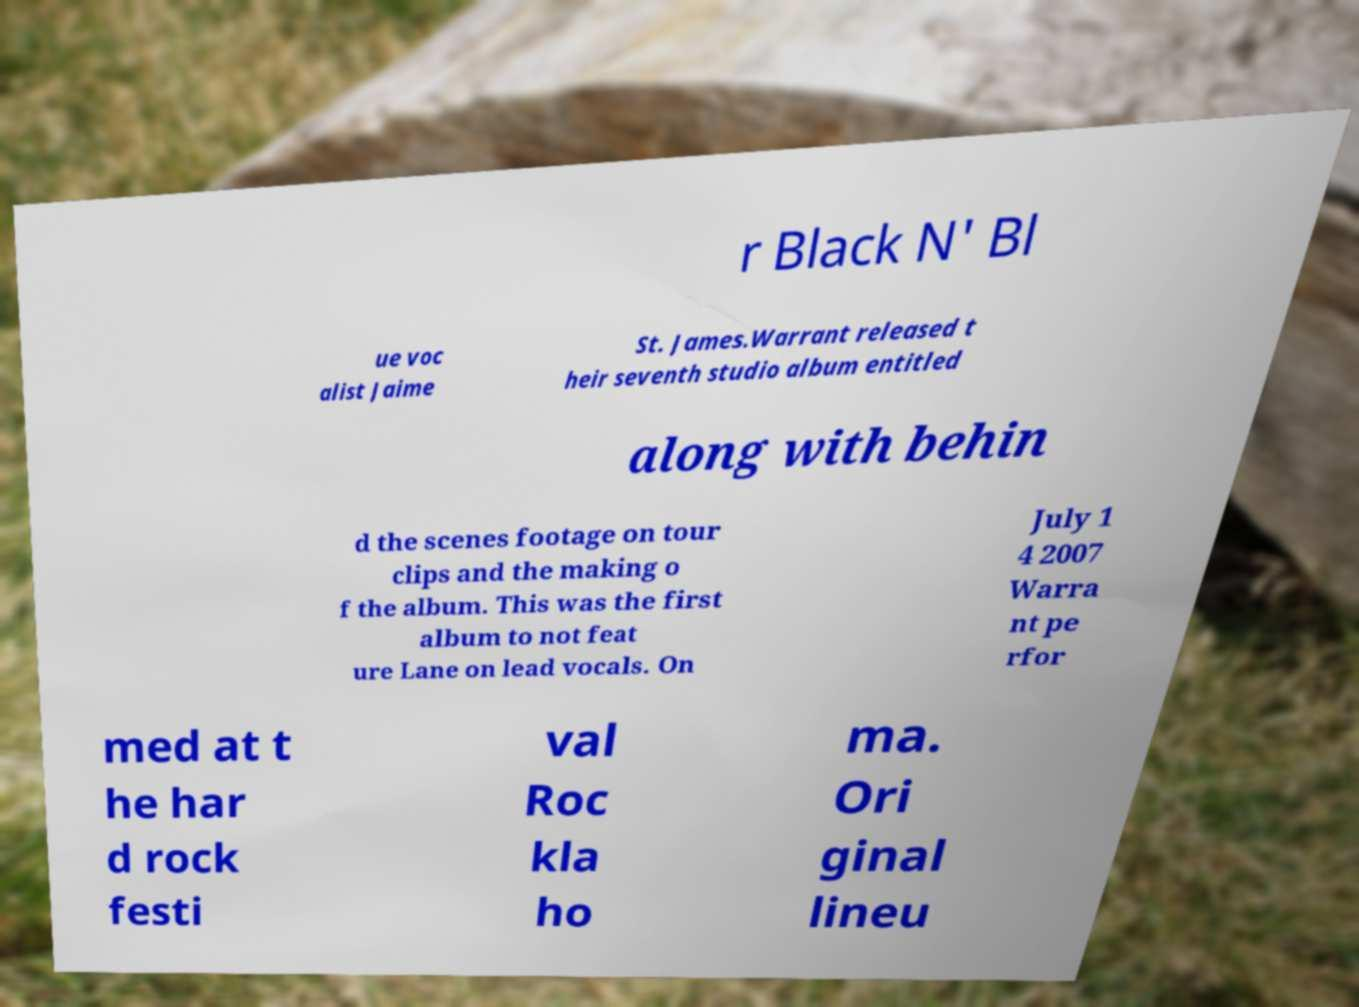Please identify and transcribe the text found in this image. r Black N' Bl ue voc alist Jaime St. James.Warrant released t heir seventh studio album entitled along with behin d the scenes footage on tour clips and the making o f the album. This was the first album to not feat ure Lane on lead vocals. On July 1 4 2007 Warra nt pe rfor med at t he har d rock festi val Roc kla ho ma. Ori ginal lineu 